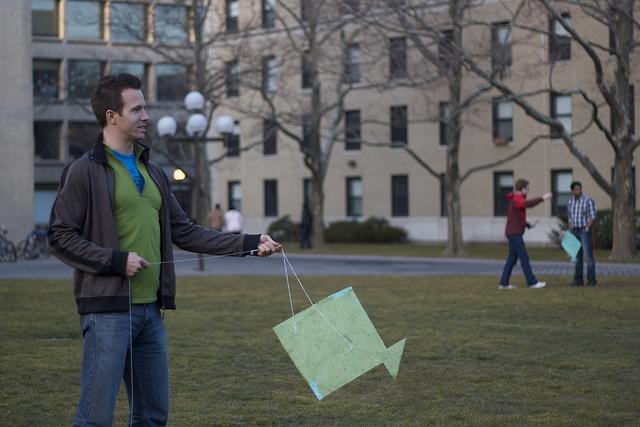Is the boy smiling?
Short answer required. No. Is he wearing a raincoat?
Keep it brief. No. What color are their pants?
Answer briefly. Blue. Is it a sunny day?
Keep it brief. No. How many men are standing on the left?
Be succinct. 1. Is the guy smiling?
Be succinct. Yes. How many windows?
Be succinct. 42. What color is the kite?
Short answer required. Green. How is the man prepared for the weather?
Answer briefly. Jacket. What is the man about to fly?
Answer briefly. Kite. What is the man carrying?
Concise answer only. Kite. Is he about to hit the ball?
Answer briefly. No. Is the building new?
Answer briefly. Yes. What is the man holding in his hand?
Answer briefly. Kite. What this boy playing with?
Write a very short answer. Kite. What is the man about to catch?
Quick response, please. Kite. What type of shirt does the man wear?
Give a very brief answer. Sweater. How many windows do you see?
Keep it brief. 37. How many glass panels are there in this image?
Quick response, please. 40. Is this man walking in the rain?
Be succinct. No. Is there a design on the kite?
Give a very brief answer. No. Do you think this photo was taken in Alaska?
Give a very brief answer. No. Is this a two story building?
Give a very brief answer. No. Where does it say West 14th?
Quick response, please. Nowhere. Is that net firm or flimsy?
Concise answer only. Flimsy. What color is his shirt?
Keep it brief. Green. Are they trying to recreate a photograph?
Quick response, please. No. What is the guy doing?
Give a very brief answer. Flying kite. Is any part of this picture darker than others?
Be succinct. No. What color is the jacket?
Keep it brief. Brown. What color is the man's t-shirt?
Quick response, please. Green. What is this person holding?
Write a very short answer. Kite. Where has the crowd gathered?
Be succinct. Park. What is on the road?
Keep it brief. Nothing. Who is holding the kite string?
Answer briefly. Man. 